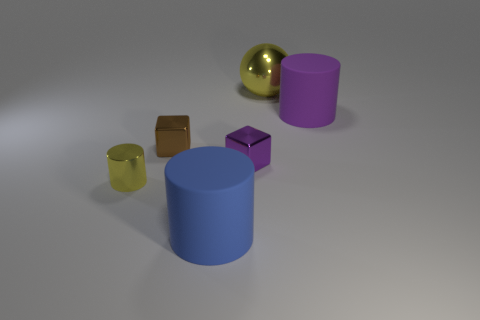Does the small purple metallic thing have the same shape as the small brown shiny object?
Provide a succinct answer. Yes. What is the material of the other large object that is the same shape as the large purple object?
Your response must be concise. Rubber. There is a tiny shiny object that is to the right of the cylinder that is in front of the tiny yellow metallic cylinder that is in front of the big yellow thing; what color is it?
Offer a terse response. Purple. How many large things are brown things or gray rubber blocks?
Ensure brevity in your answer.  0. Are there an equal number of big yellow balls that are behind the sphere and small brown spheres?
Offer a very short reply. Yes. Are there any tiny purple metallic objects in front of the big purple matte cylinder?
Your answer should be compact. Yes. How many metal things are purple things or tiny objects?
Ensure brevity in your answer.  3. There is a purple cylinder; what number of cubes are in front of it?
Provide a short and direct response. 2. Is there a thing that has the same size as the purple rubber cylinder?
Give a very brief answer. Yes. Are there any other metal things that have the same color as the large metallic thing?
Your response must be concise. Yes. 